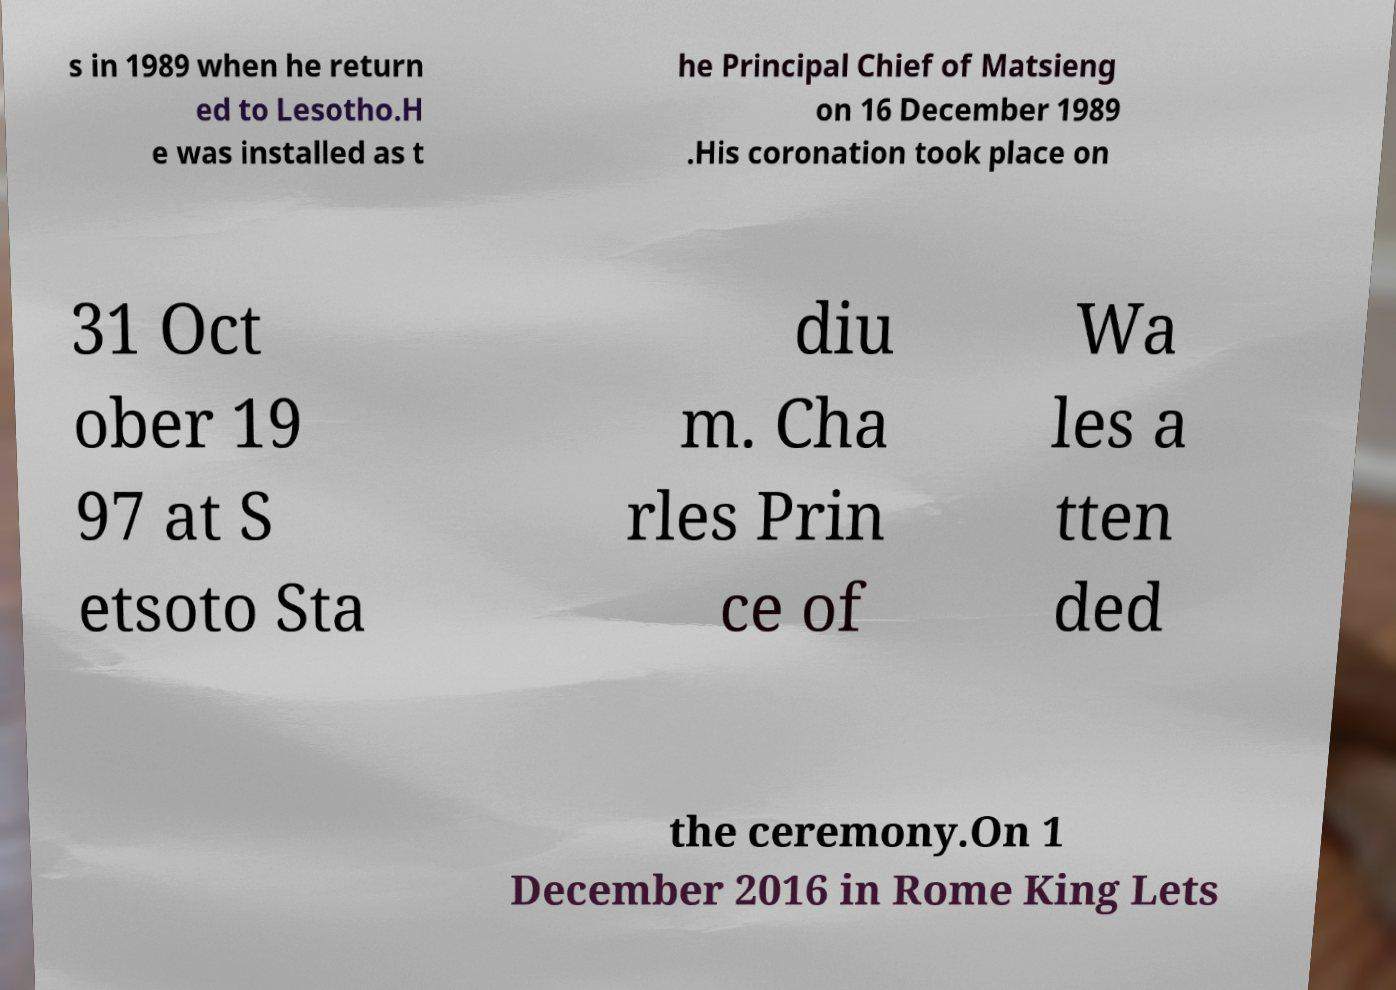Please identify and transcribe the text found in this image. s in 1989 when he return ed to Lesotho.H e was installed as t he Principal Chief of Matsieng on 16 December 1989 .His coronation took place on 31 Oct ober 19 97 at S etsoto Sta diu m. Cha rles Prin ce of Wa les a tten ded the ceremony.On 1 December 2016 in Rome King Lets 